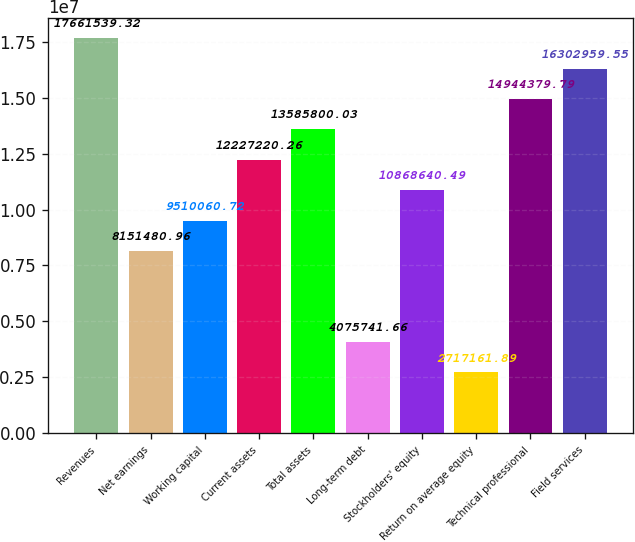Convert chart to OTSL. <chart><loc_0><loc_0><loc_500><loc_500><bar_chart><fcel>Revenues<fcel>Net earnings<fcel>Working capital<fcel>Current assets<fcel>Total assets<fcel>Long-term debt<fcel>Stockholders' equity<fcel>Return on average equity<fcel>Technical professional<fcel>Field services<nl><fcel>1.76615e+07<fcel>8.15148e+06<fcel>9.51006e+06<fcel>1.22272e+07<fcel>1.35858e+07<fcel>4.07574e+06<fcel>1.08686e+07<fcel>2.71716e+06<fcel>1.49444e+07<fcel>1.6303e+07<nl></chart> 